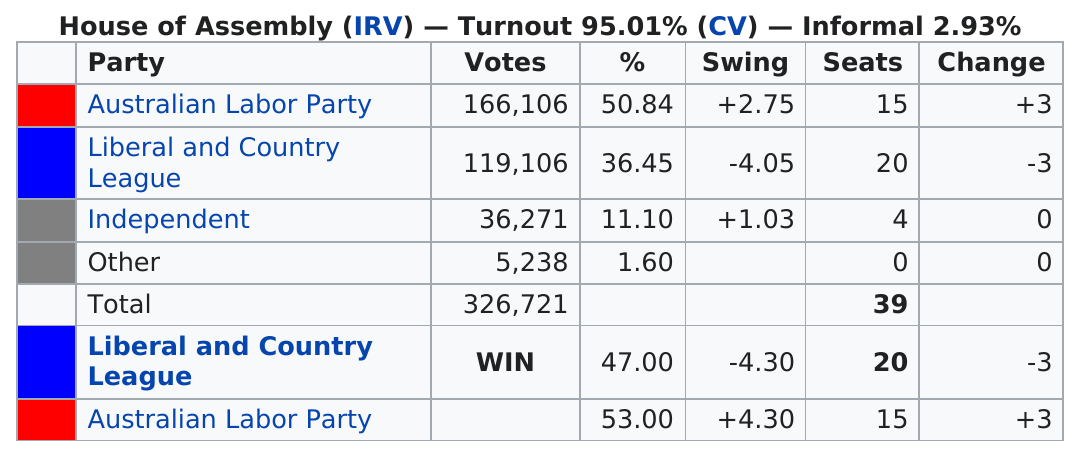Outline some significant characteristics in this image. The party that had the least number of seats was Other. After the election, the Liberal and Country League emerged as the party with the most seats in the parliament. According to the data provided, the Independent party received 36,271 votes in the most recent election. The Australian Labor Party received the most votes in the election. The party that received more than 30,000 votes but did not gain any seats in the parliament was the Independent party. 